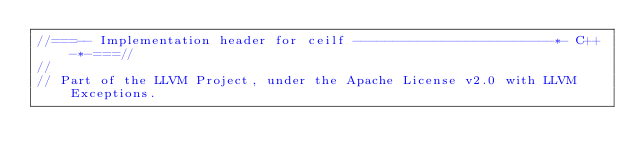Convert code to text. <code><loc_0><loc_0><loc_500><loc_500><_C_>//===-- Implementation header for ceilf -------------------------*- C++ -*-===//
//
// Part of the LLVM Project, under the Apache License v2.0 with LLVM Exceptions.</code> 